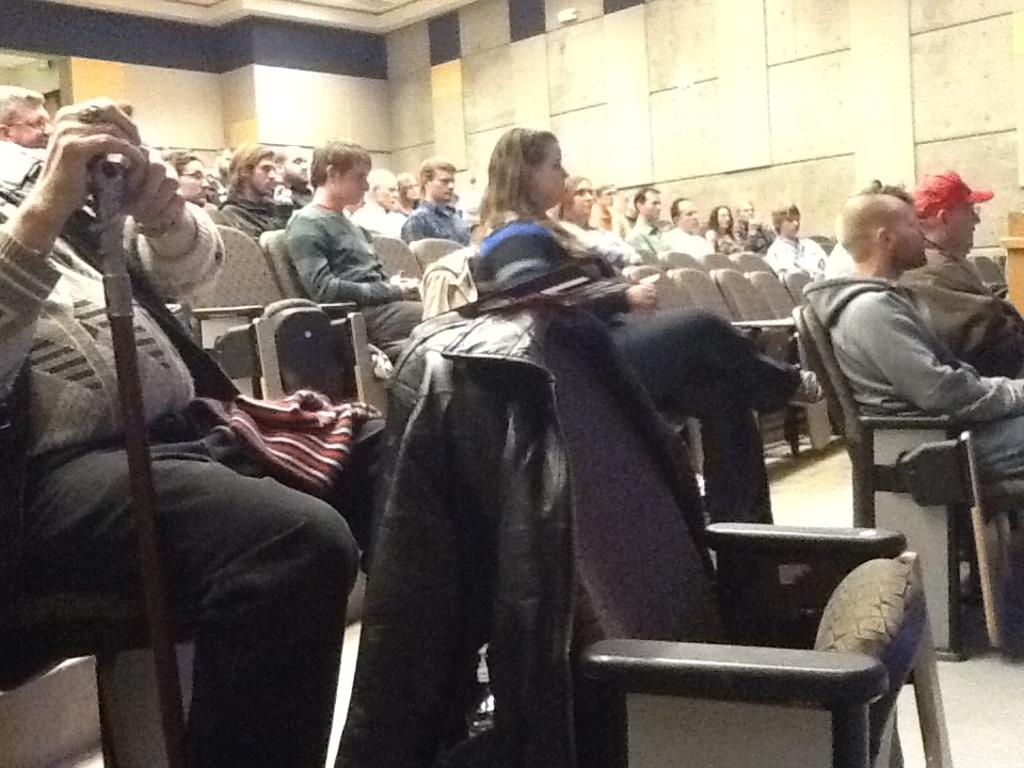How many individuals are present in the image? There are many people in the image. Can you describe the clothing of one of the individuals? There is a man wearing a jacket in the image. What is the man doing in the image? The man is sitting on a chair. Who is in the middle of the image? There is a woman in the middle of the image. What can be seen in the background of the image? There is a wall in the background of the image. What type of rake is being used by the woman in the image? There is no rake present in the image; it features a gathering of people with a man sitting on a chair and a woman in the middle. 